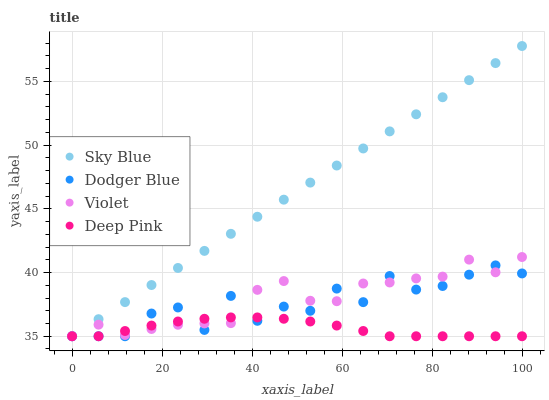Does Deep Pink have the minimum area under the curve?
Answer yes or no. Yes. Does Sky Blue have the maximum area under the curve?
Answer yes or no. Yes. Does Dodger Blue have the minimum area under the curve?
Answer yes or no. No. Does Dodger Blue have the maximum area under the curve?
Answer yes or no. No. Is Sky Blue the smoothest?
Answer yes or no. Yes. Is Dodger Blue the roughest?
Answer yes or no. Yes. Is Deep Pink the smoothest?
Answer yes or no. No. Is Deep Pink the roughest?
Answer yes or no. No. Does Sky Blue have the lowest value?
Answer yes or no. Yes. Does Sky Blue have the highest value?
Answer yes or no. Yes. Does Dodger Blue have the highest value?
Answer yes or no. No. Does Violet intersect Dodger Blue?
Answer yes or no. Yes. Is Violet less than Dodger Blue?
Answer yes or no. No. Is Violet greater than Dodger Blue?
Answer yes or no. No. 